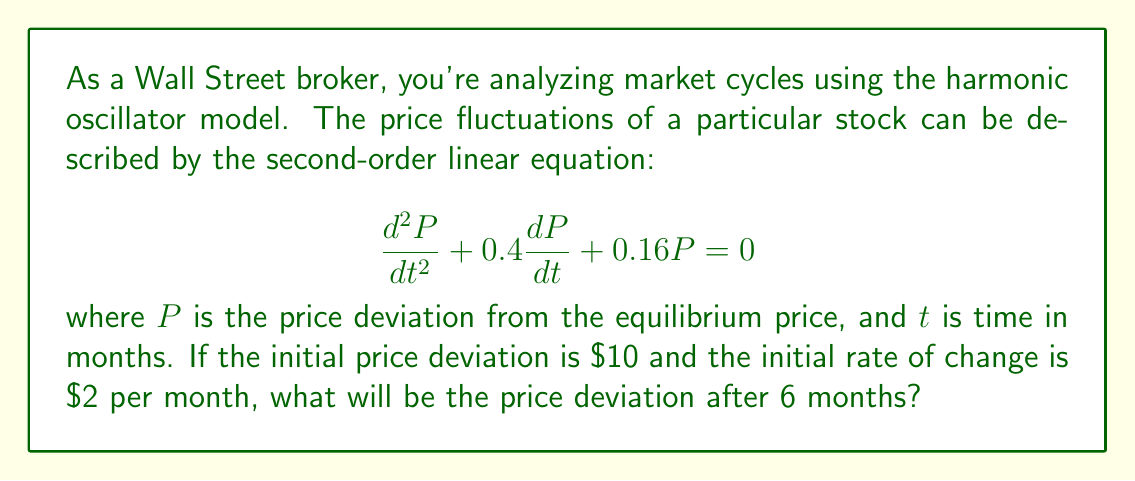Help me with this question. To solve this problem, we need to follow these steps:

1) The general solution for this second-order linear equation is:

   $$P(t) = e^{-0.2t}(A\cos(0.4t) + B\sin(0.4t))$$

   where $A$ and $B$ are constants determined by the initial conditions.

2) We have two initial conditions:
   - $P(0) = 10$ (initial price deviation)
   - $P'(0) = 2$ (initial rate of change)

3) Using the first condition:
   
   $$P(0) = A = 10$$

4) To use the second condition, we need to find $P'(t)$:

   $$P'(t) = e^{-0.2t}(-0.2A\cos(0.4t) - 0.2B\sin(0.4t) - 0.4A\sin(0.4t) + 0.4B\cos(0.4t))$$

5) Applying the second condition:

   $$P'(0) = -0.2A + 0.4B = 2$$
   $$-0.2(10) + 0.4B = 2$$
   $$0.4B = 4$$
   $$B = 10$$

6) Now we have the complete solution:

   $$P(t) = e^{-0.2t}(10\cos(0.4t) + 10\sin(0.4t))$$

7) To find the price deviation after 6 months, we calculate $P(6)$:

   $$P(6) = e^{-0.2(6)}(10\cos(0.4(6)) + 10\sin(0.4(6)))$$
   $$= e^{-1.2}(10\cos(2.4) + 10\sin(2.4))$$
   $$\approx 0.301(10(-0.7373) + 10(0.6755))$$
   $$\approx 0.301(-0.618)$$
   $$\approx -0.186$$

Therefore, the price deviation after 6 months will be approximately -$0.186.
Answer: $-0.186 or approximately -$0.19 